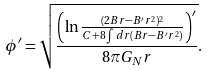<formula> <loc_0><loc_0><loc_500><loc_500>\phi ^ { \prime } = \sqrt { \frac { \left ( \ln { \frac { ( 2 B r - B ^ { \prime } r ^ { 2 } ) ^ { 2 } } { C + 8 \int d r { ( B r - B ^ { \prime } r ^ { 2 } ) } } } \right ) ^ { \prime } } { 8 \pi G _ { N } r } } .</formula> 